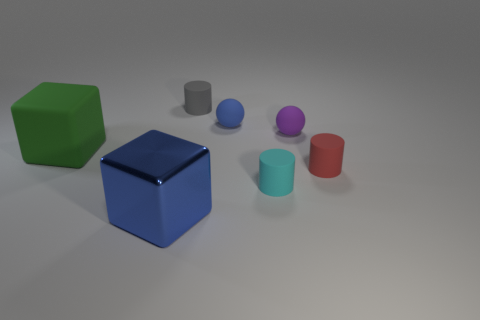How big is the blue object to the right of the gray thing?
Provide a succinct answer. Small. There is a blue thing that is to the left of the small rubber cylinder behind the purple rubber thing; what number of blue cubes are right of it?
Your answer should be compact. 0. There is a small red matte cylinder; are there any tiny matte cylinders behind it?
Provide a short and direct response. Yes. What number of other things are the same size as the gray object?
Your answer should be very brief. 4. What material is the thing that is in front of the green rubber thing and on the left side of the tiny blue matte ball?
Offer a very short reply. Metal. There is a large thing on the right side of the big green block; is it the same shape as the big object that is behind the small cyan rubber thing?
Make the answer very short. Yes. Is there any other thing that is the same material as the blue cube?
Give a very brief answer. No. What is the shape of the tiny blue thing that is behind the sphere that is to the right of the blue object that is to the right of the large metallic block?
Make the answer very short. Sphere. What number of other objects are the same shape as the small purple matte thing?
Your answer should be very brief. 1. What is the color of the other rubber sphere that is the same size as the blue matte ball?
Offer a terse response. Purple. 